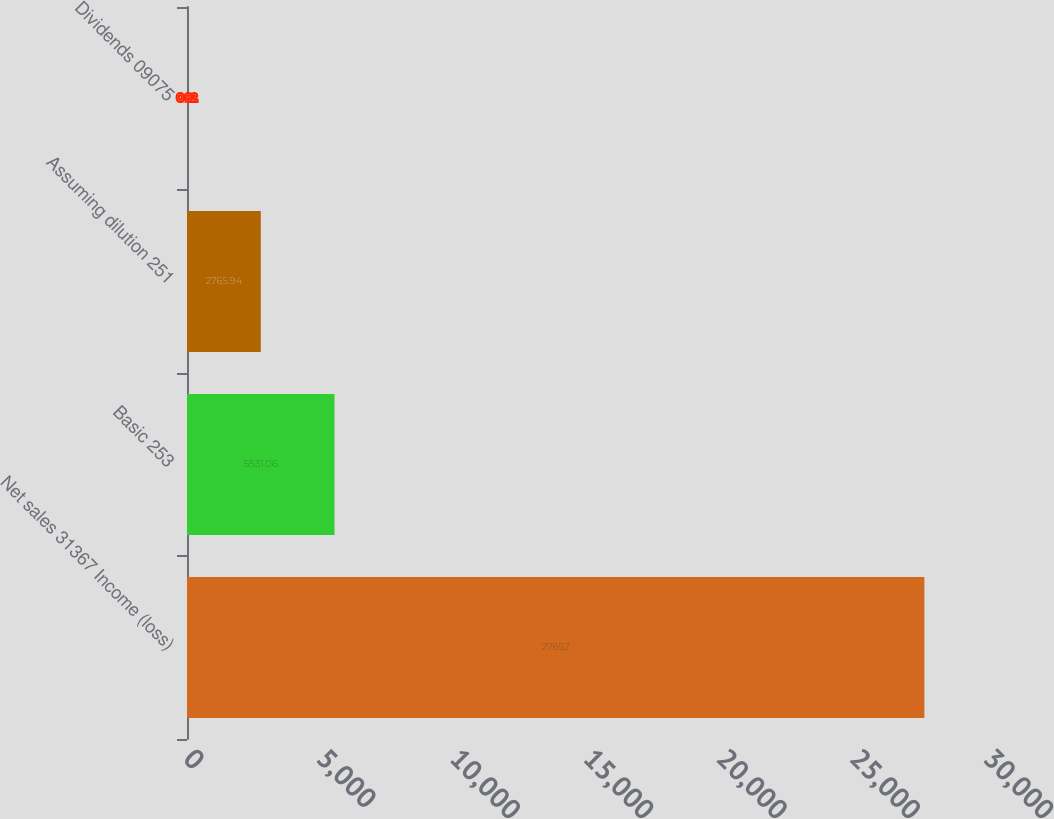<chart> <loc_0><loc_0><loc_500><loc_500><bar_chart><fcel>Net sales 31367 Income (loss)<fcel>Basic 253<fcel>Assuming dilution 251<fcel>Dividends 09075<nl><fcel>27652<fcel>5531.06<fcel>2765.94<fcel>0.82<nl></chart> 